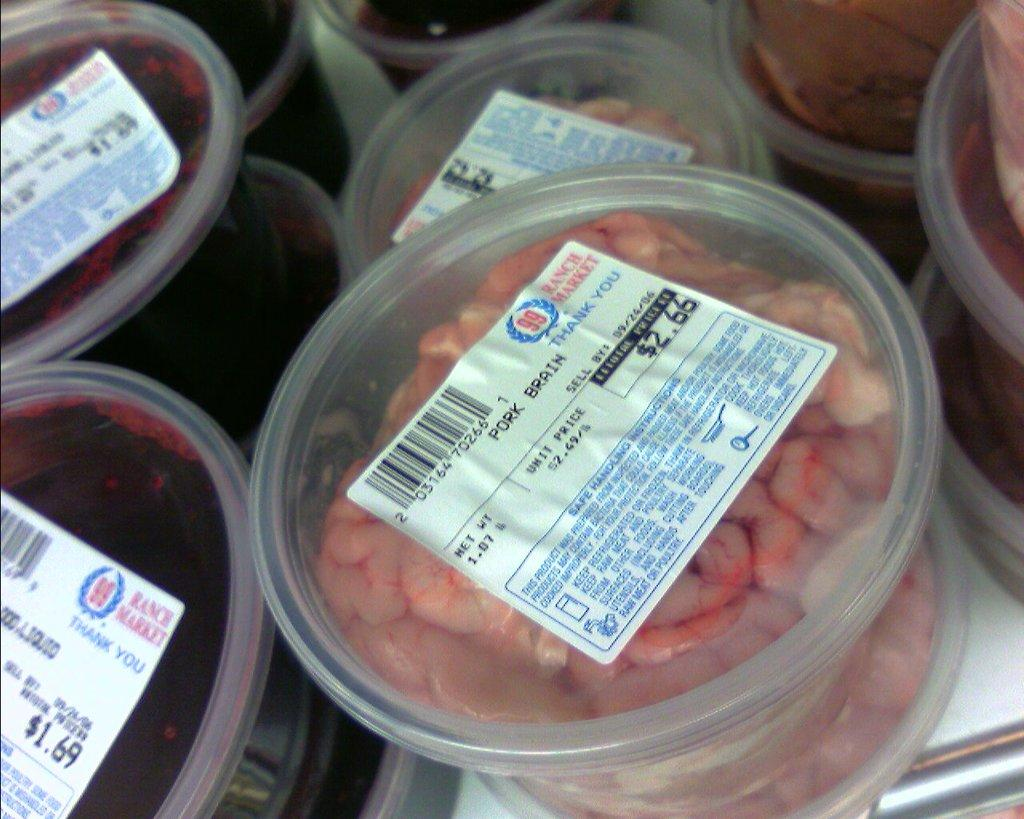What type of containers are visible in the image? There are plastic boxes in the image. What is inside the plastic boxes? The plastic boxes contain food items. How can the price of the items be determined? There are price stickers on top of the boxes, which have bar codes on them. Where is the parent sitting on the stage in the image? There is no stage or parent present in the image; it only features plastic boxes with food items and price stickers. 